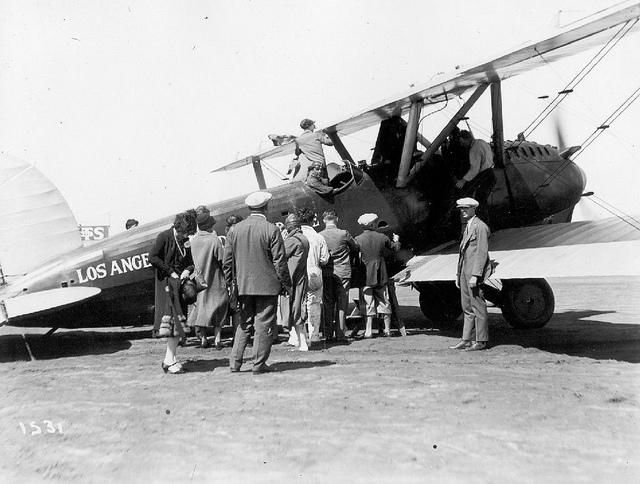How many people are in this picture?
Answer briefly. 12. What text is on the tail of the plane?
Quick response, please. Los angeles. What kind of plane is it?
Be succinct. Biplane. 